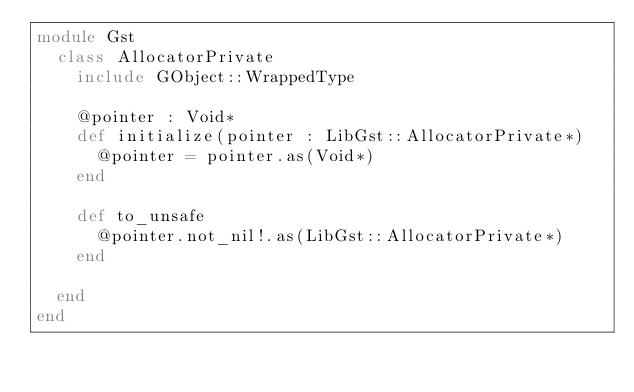<code> <loc_0><loc_0><loc_500><loc_500><_Crystal_>module Gst
  class AllocatorPrivate
    include GObject::WrappedType

    @pointer : Void*
    def initialize(pointer : LibGst::AllocatorPrivate*)
      @pointer = pointer.as(Void*)
    end

    def to_unsafe
      @pointer.not_nil!.as(LibGst::AllocatorPrivate*)
    end

  end
end

</code> 